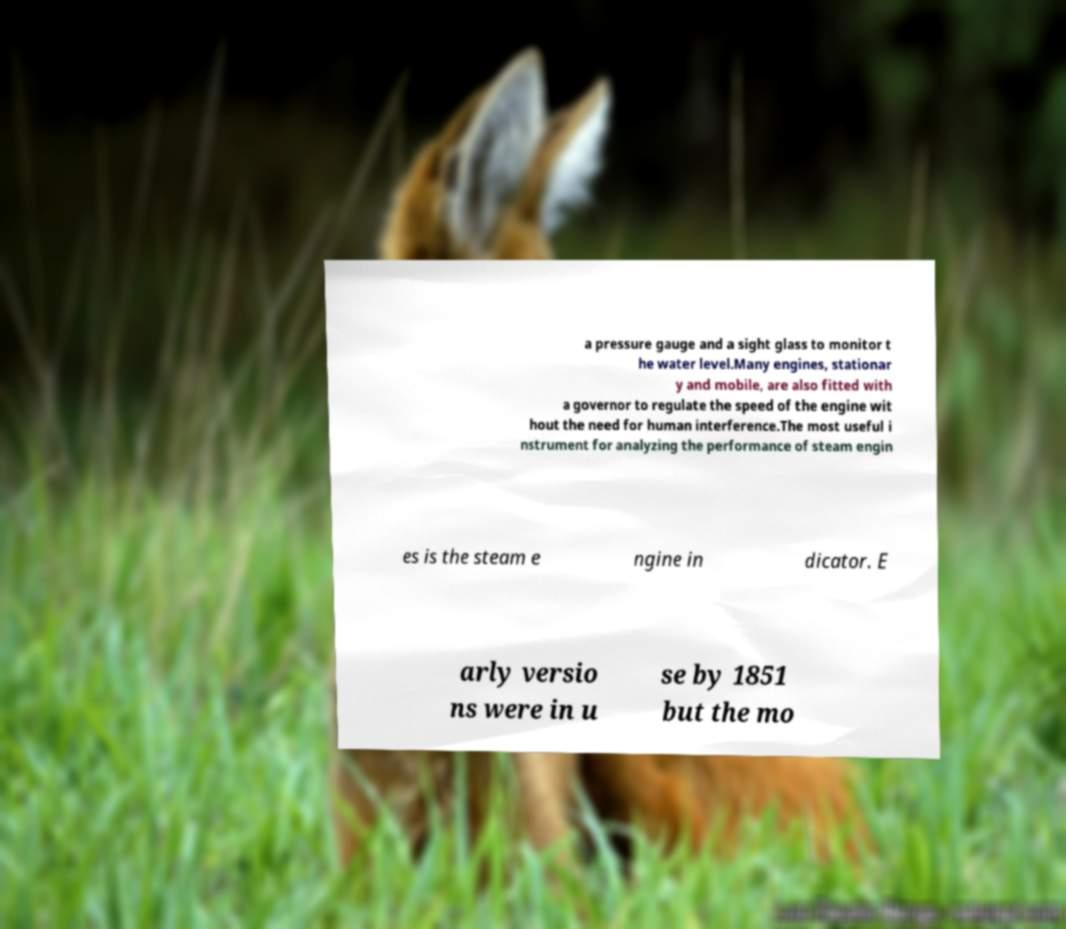Could you assist in decoding the text presented in this image and type it out clearly? a pressure gauge and a sight glass to monitor t he water level.Many engines, stationar y and mobile, are also fitted with a governor to regulate the speed of the engine wit hout the need for human interference.The most useful i nstrument for analyzing the performance of steam engin es is the steam e ngine in dicator. E arly versio ns were in u se by 1851 but the mo 